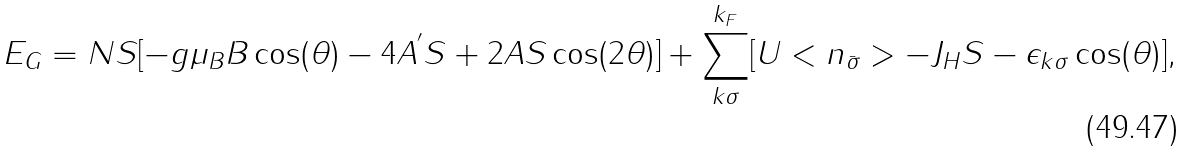<formula> <loc_0><loc_0><loc_500><loc_500>E _ { G } = N S [ - g \mu _ { B } B \cos ( \theta ) - 4 A ^ { ^ { \prime } } S + 2 A S \cos ( 2 \theta ) ] + \sum _ { k \sigma } ^ { k _ { F } } [ U < n _ { \bar { \sigma } } > - J _ { H } S - \epsilon _ { k \sigma } \cos ( \theta ) ] ,</formula> 